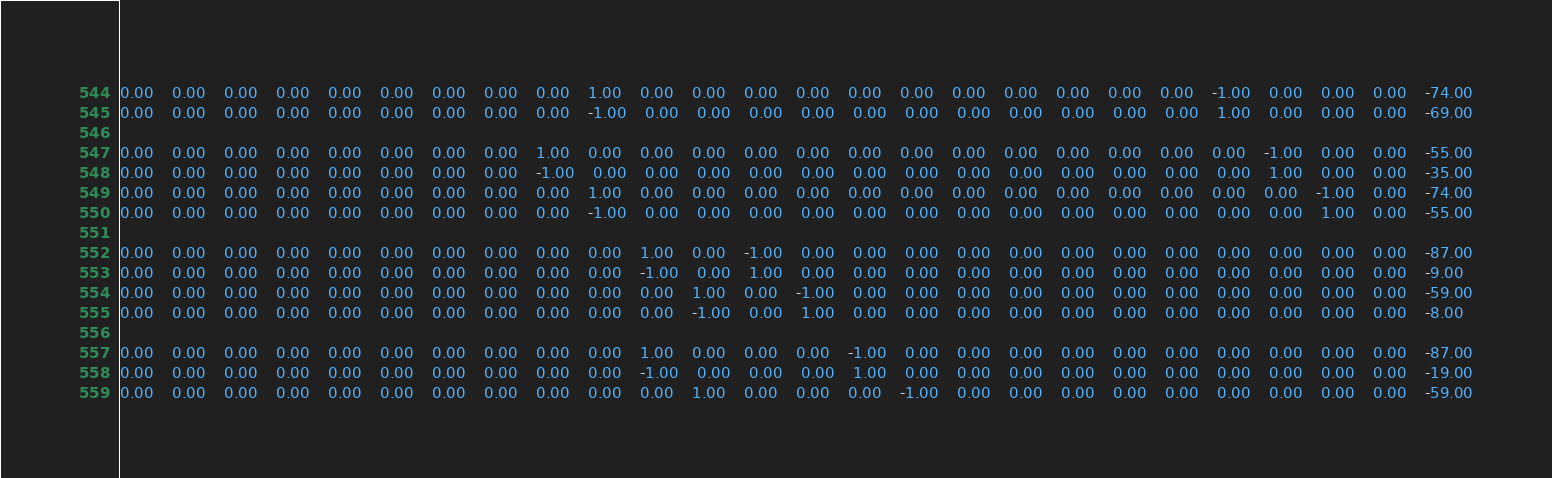<code> <loc_0><loc_0><loc_500><loc_500><_Matlab_>0.00	0.00	0.00	0.00	0.00	0.00	0.00	0.00	0.00	1.00	0.00	0.00	0.00	0.00	0.00	0.00	0.00	0.00	0.00	0.00	0.00	-1.00	0.00	0.00	0.00	-74.00
0.00	0.00	0.00	0.00	0.00	0.00	0.00	0.00	0.00	-1.00	0.00	0.00	0.00	0.00	0.00	0.00	0.00	0.00	0.00	0.00	0.00	1.00	0.00	0.00	0.00	-69.00

0.00	0.00	0.00	0.00	0.00	0.00	0.00	0.00	1.00	0.00	0.00	0.00	0.00	0.00	0.00	0.00	0.00	0.00	0.00	0.00	0.00	0.00	-1.00	0.00	0.00	-55.00
0.00	0.00	0.00	0.00	0.00	0.00	0.00	0.00	-1.00	0.00	0.00	0.00	0.00	0.00	0.00	0.00	0.00	0.00	0.00	0.00	0.00	0.00	1.00	0.00	0.00	-35.00
0.00	0.00	0.00	0.00	0.00	0.00	0.00	0.00	0.00	1.00	0.00	0.00	0.00	0.00	0.00	0.00	0.00	0.00	0.00	0.00	0.00	0.00	0.00	-1.00	0.00	-74.00
0.00	0.00	0.00	0.00	0.00	0.00	0.00	0.00	0.00	-1.00	0.00	0.00	0.00	0.00	0.00	0.00	0.00	0.00	0.00	0.00	0.00	0.00	0.00	1.00	0.00	-55.00

0.00	0.00	0.00	0.00	0.00	0.00	0.00	0.00	0.00	0.00	1.00	0.00	-1.00	0.00	0.00	0.00	0.00	0.00	0.00	0.00	0.00	0.00	0.00	0.00	0.00	-87.00
0.00	0.00	0.00	0.00	0.00	0.00	0.00	0.00	0.00	0.00	-1.00	0.00	1.00	0.00	0.00	0.00	0.00	0.00	0.00	0.00	0.00	0.00	0.00	0.00	0.00	-9.00
0.00	0.00	0.00	0.00	0.00	0.00	0.00	0.00	0.00	0.00	0.00	1.00	0.00	-1.00	0.00	0.00	0.00	0.00	0.00	0.00	0.00	0.00	0.00	0.00	0.00	-59.00
0.00	0.00	0.00	0.00	0.00	0.00	0.00	0.00	0.00	0.00	0.00	-1.00	0.00	1.00	0.00	0.00	0.00	0.00	0.00	0.00	0.00	0.00	0.00	0.00	0.00	-8.00

0.00	0.00	0.00	0.00	0.00	0.00	0.00	0.00	0.00	0.00	1.00	0.00	0.00	0.00	-1.00	0.00	0.00	0.00	0.00	0.00	0.00	0.00	0.00	0.00	0.00	-87.00
0.00	0.00	0.00	0.00	0.00	0.00	0.00	0.00	0.00	0.00	-1.00	0.00	0.00	0.00	1.00	0.00	0.00	0.00	0.00	0.00	0.00	0.00	0.00	0.00	0.00	-19.00
0.00	0.00	0.00	0.00	0.00	0.00	0.00	0.00	0.00	0.00	0.00	1.00	0.00	0.00	0.00	-1.00	0.00	0.00	0.00	0.00	0.00	0.00	0.00	0.00	0.00	-59.00</code> 